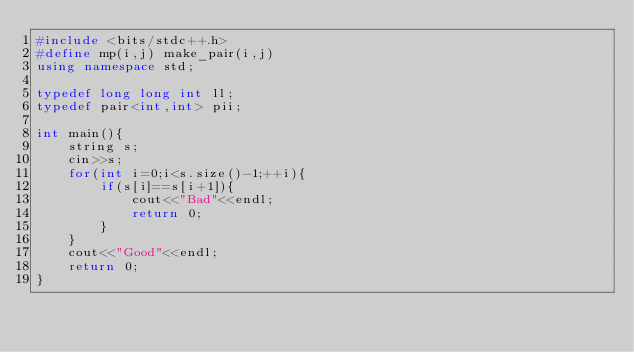Convert code to text. <code><loc_0><loc_0><loc_500><loc_500><_C++_>#include <bits/stdc++.h>
#define mp(i,j) make_pair(i,j)
using namespace std;

typedef long long int ll;
typedef pair<int,int> pii;

int main(){
	string s;
	cin>>s;
	for(int i=0;i<s.size()-1;++i){
		if(s[i]==s[i+1]){
			cout<<"Bad"<<endl;
			return 0;
		}
	}
	cout<<"Good"<<endl;
	return 0;
}</code> 